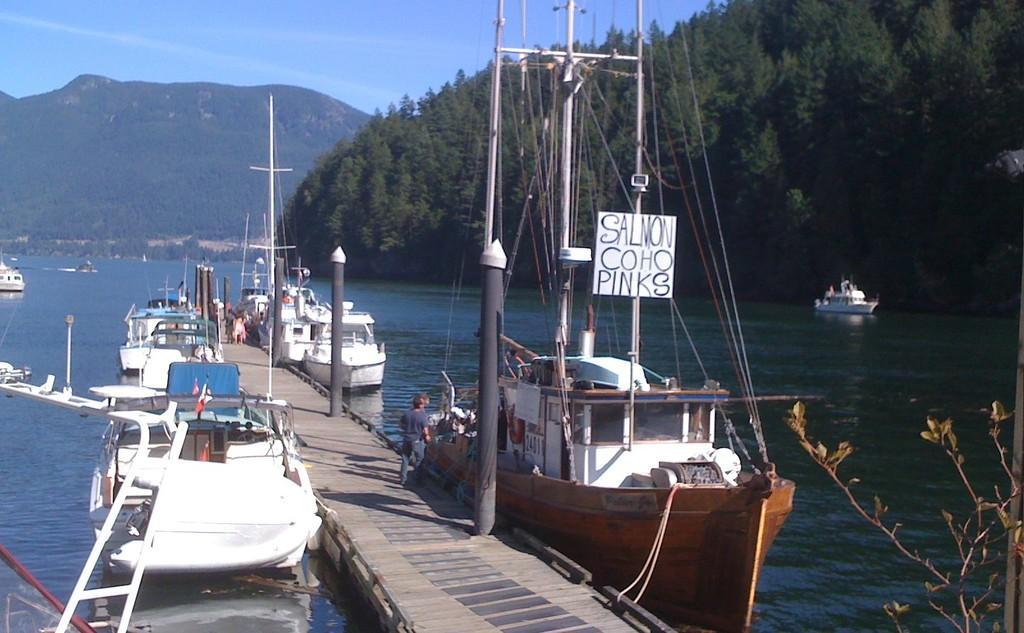How would you summarize this image in a sentence or two? In the center of the image we can see a board bridge. There is water and we can see boats on the water. We can see people. In the background there are hills and sky. We can see trees. 